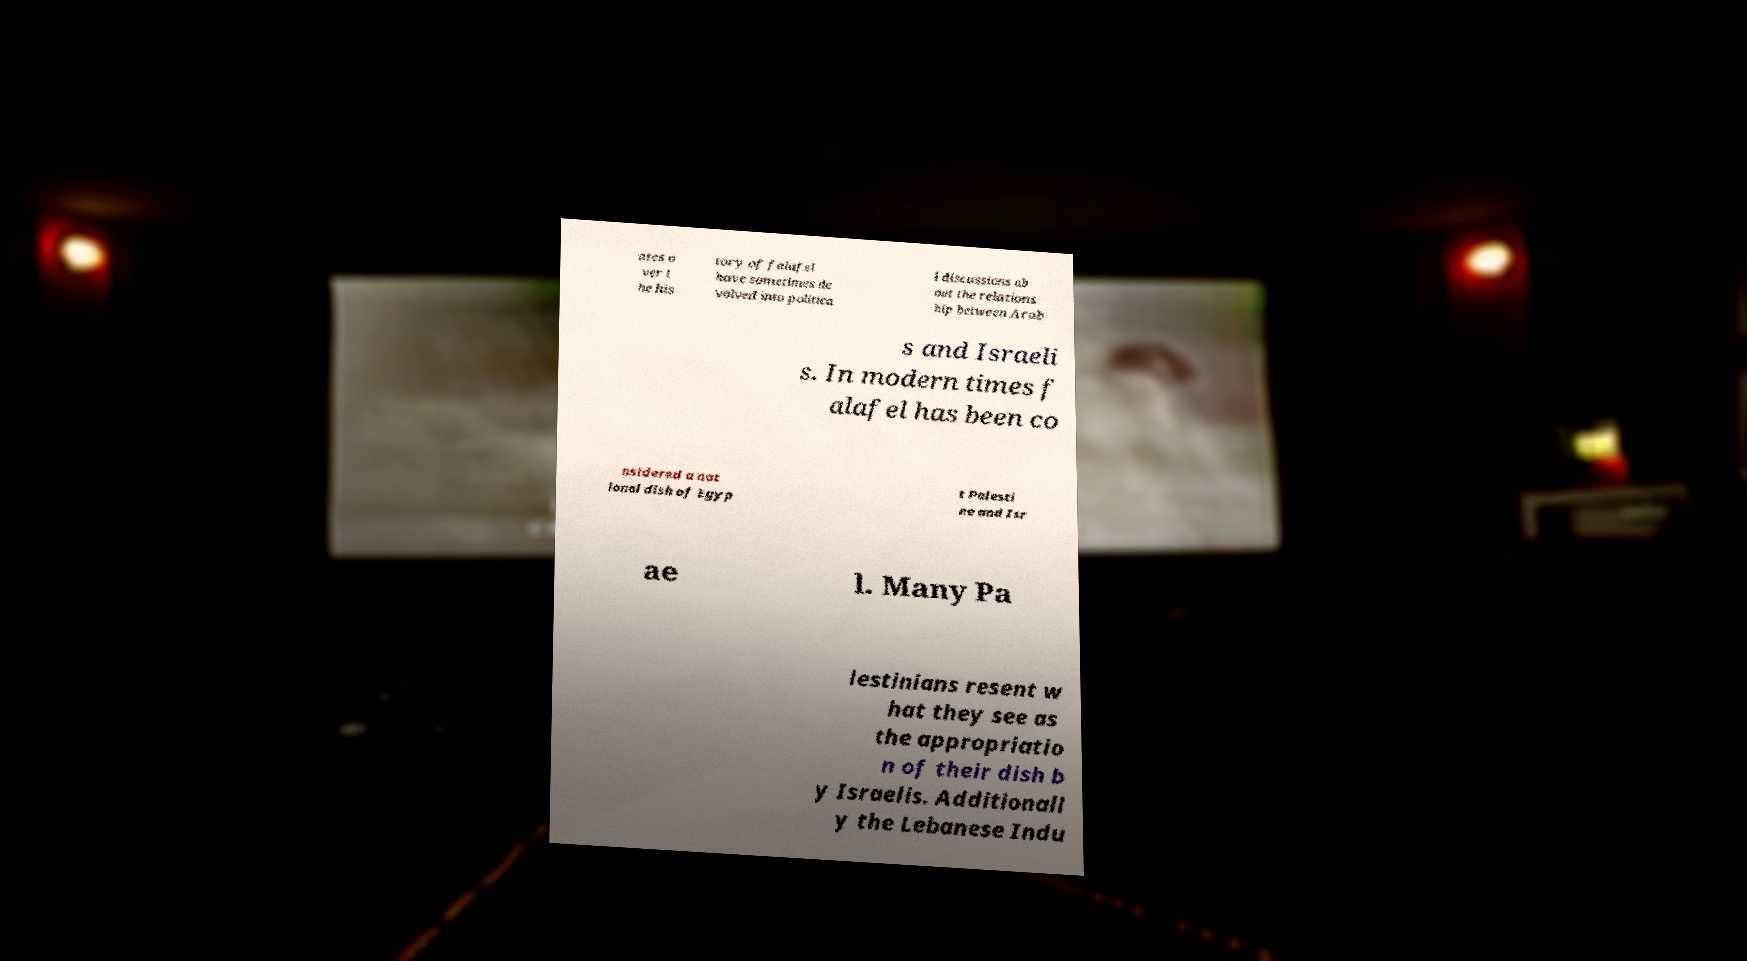Please identify and transcribe the text found in this image. ates o ver t he his tory of falafel have sometimes de volved into politica l discussions ab out the relations hip between Arab s and Israeli s. In modern times f alafel has been co nsidered a nat ional dish of Egyp t Palesti ne and Isr ae l. Many Pa lestinians resent w hat they see as the appropriatio n of their dish b y Israelis. Additionall y the Lebanese Indu 